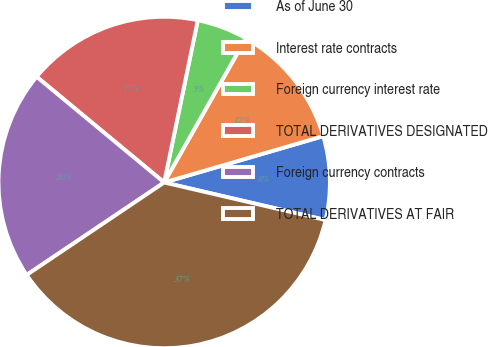Convert chart. <chart><loc_0><loc_0><loc_500><loc_500><pie_chart><fcel>As of June 30<fcel>Interest rate contracts<fcel>Foreign currency interest rate<fcel>TOTAL DERIVATIVES DESIGNATED<fcel>Foreign currency contracts<fcel>TOTAL DERIVATIVES AT FAIR<nl><fcel>8.15%<fcel>12.29%<fcel>4.95%<fcel>17.24%<fcel>20.44%<fcel>36.94%<nl></chart> 